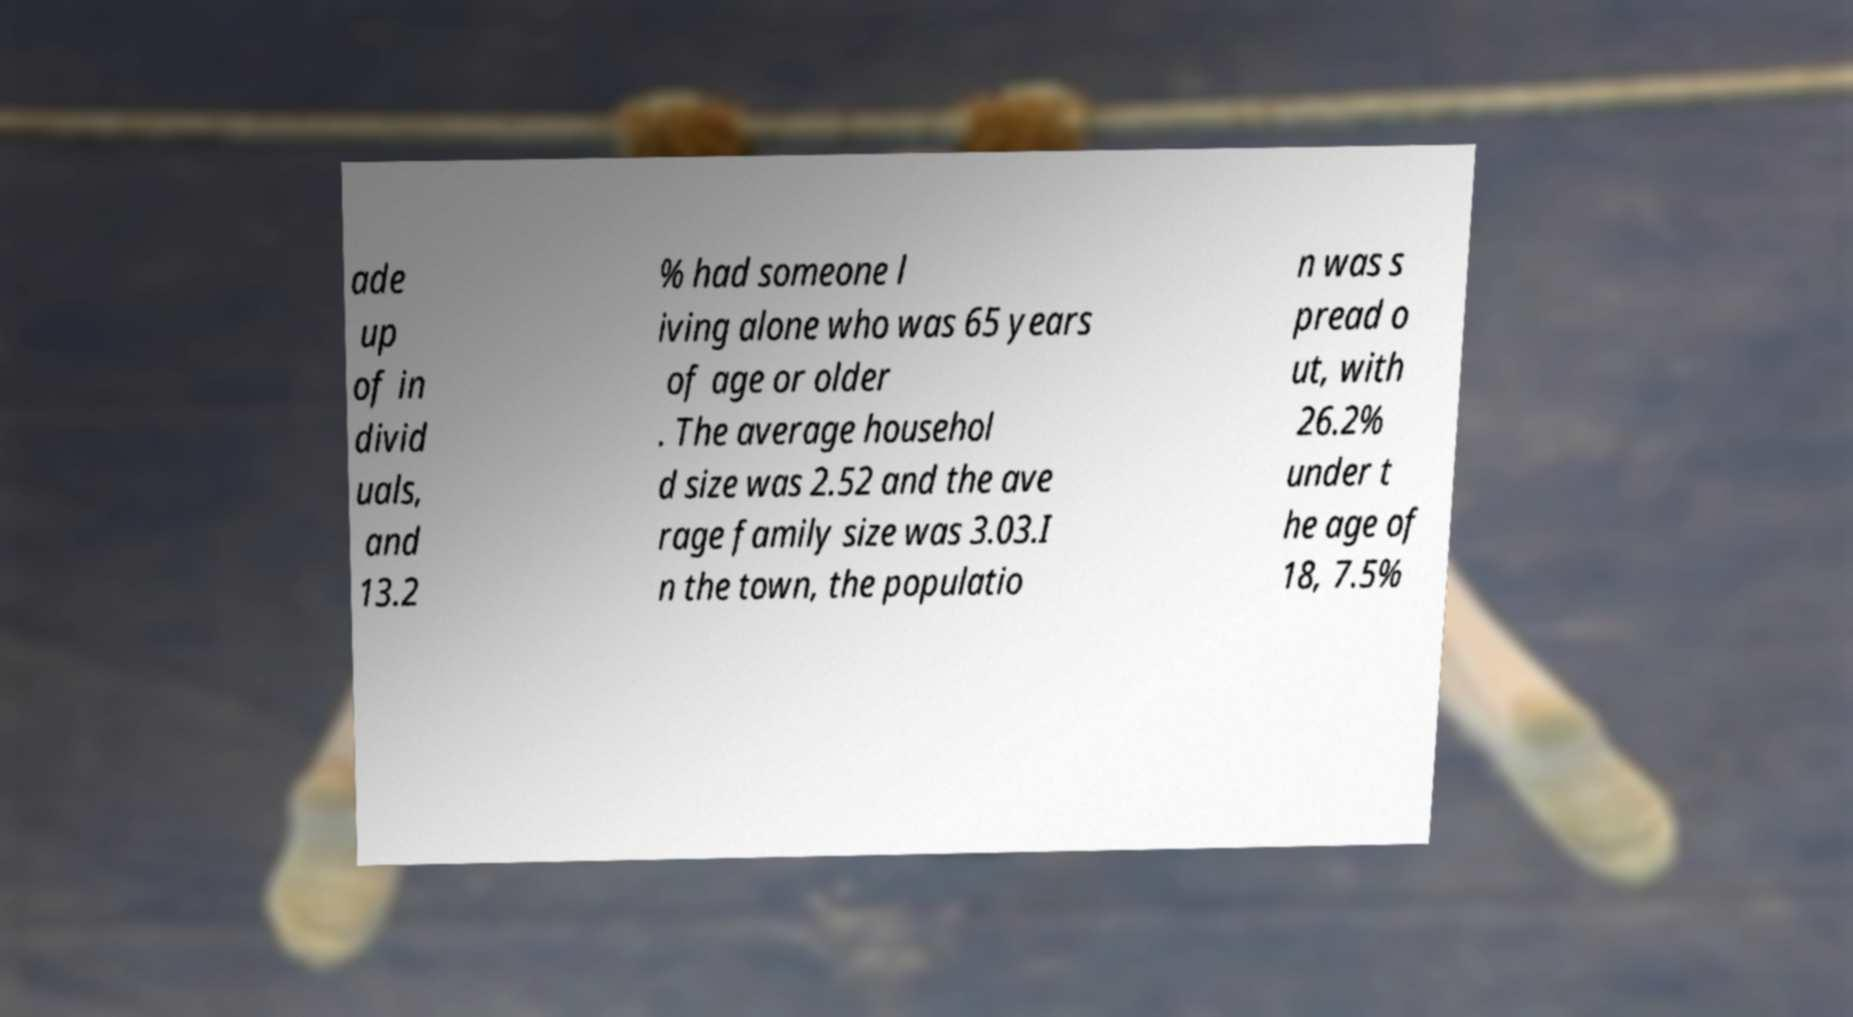Can you read and provide the text displayed in the image?This photo seems to have some interesting text. Can you extract and type it out for me? ade up of in divid uals, and 13.2 % had someone l iving alone who was 65 years of age or older . The average househol d size was 2.52 and the ave rage family size was 3.03.I n the town, the populatio n was s pread o ut, with 26.2% under t he age of 18, 7.5% 